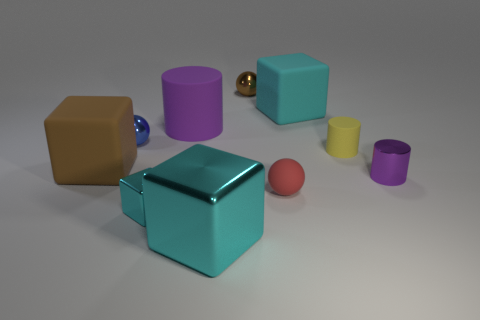How many other things are the same color as the large cylinder?
Your answer should be very brief. 1. What number of big purple objects have the same shape as the small blue thing?
Your answer should be very brief. 0. Are any purple rubber cubes visible?
Make the answer very short. No. Does the small cyan block have the same material as the cube that is to the right of the tiny brown thing?
Your answer should be very brief. No. What material is the cyan thing that is the same size as the red sphere?
Make the answer very short. Metal. Are there any cyan balls that have the same material as the large purple cylinder?
Make the answer very short. No. There is a blue metallic thing in front of the small shiny thing that is behind the big cyan rubber thing; are there any blocks that are left of it?
Offer a terse response. Yes. There is a blue object that is the same size as the red rubber ball; what is its shape?
Make the answer very short. Sphere. There is a thing that is to the right of the yellow cylinder; is it the same size as the cyan object behind the red sphere?
Give a very brief answer. No. How many small red things are there?
Make the answer very short. 1. 